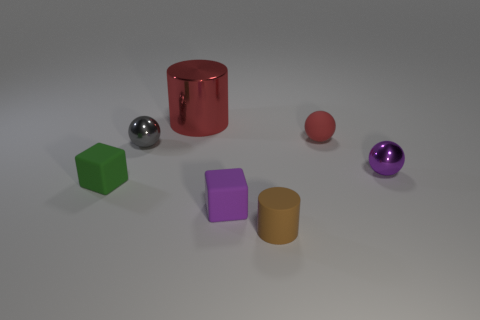Add 3 tiny green rubber objects. How many objects exist? 10 Subtract all balls. How many objects are left? 4 Subtract 1 red balls. How many objects are left? 6 Subtract all small purple matte cubes. Subtract all metallic spheres. How many objects are left? 4 Add 4 small gray things. How many small gray things are left? 5 Add 5 large brown cylinders. How many large brown cylinders exist? 5 